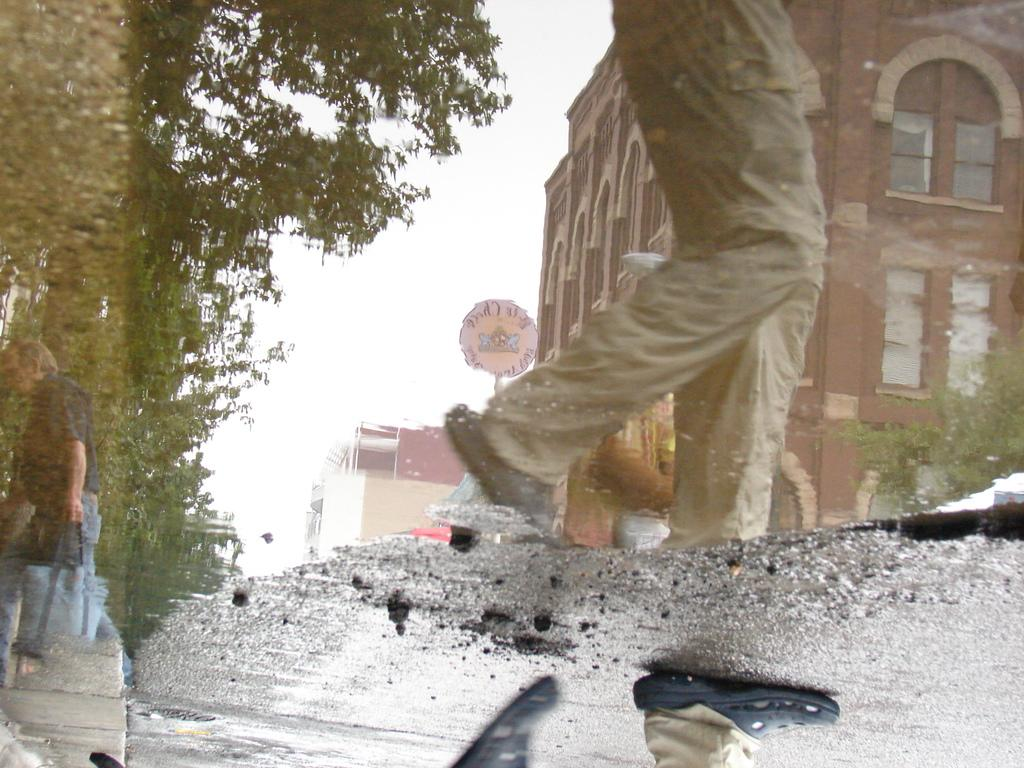What is covering the road in the image? There is water on the road in the image. What can be seen in the water due to the reflection? There is a reflection of people, buildings, a name board, and trees in the water. What type of meat can be seen hanging from the trees in the image? There is no meat present in the image; it only shows reflections of trees and other objects in the water. 